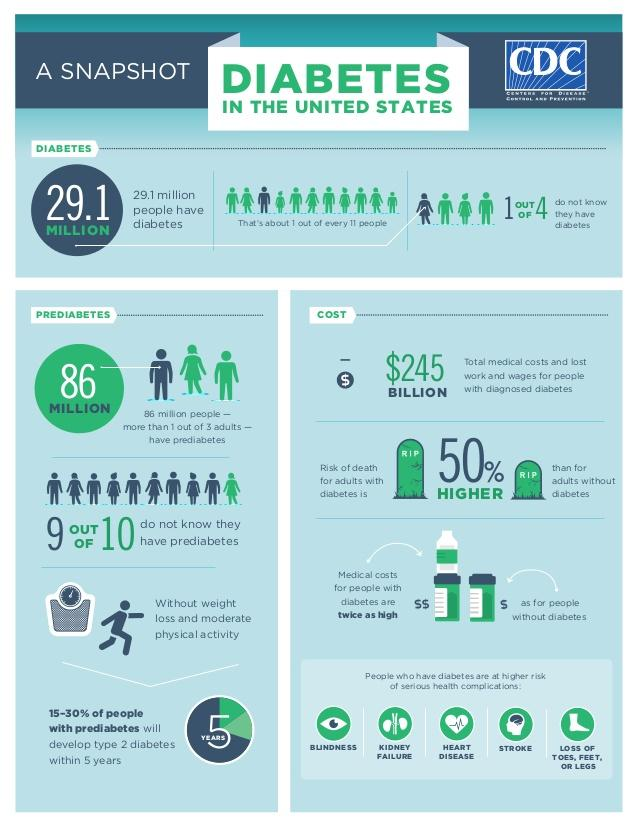Identify some key points in this picture. Without weight loss and moderate physical activity, approximately 15-30% of individuals with prediabetes are likely to develop type 2 diabetes within 5 years. Diabetes can pose a significant health risk to the eyes, potentially leading to blindness. The health risks to the brain due to diabetes and stroke are significant and can lead to long-term damage or even death. According to recent studies, approximately 90% of individuals who have prediabetes are unaware of their condition. Approximately 25% of individuals with diabetes are unaware that they have the condition. 